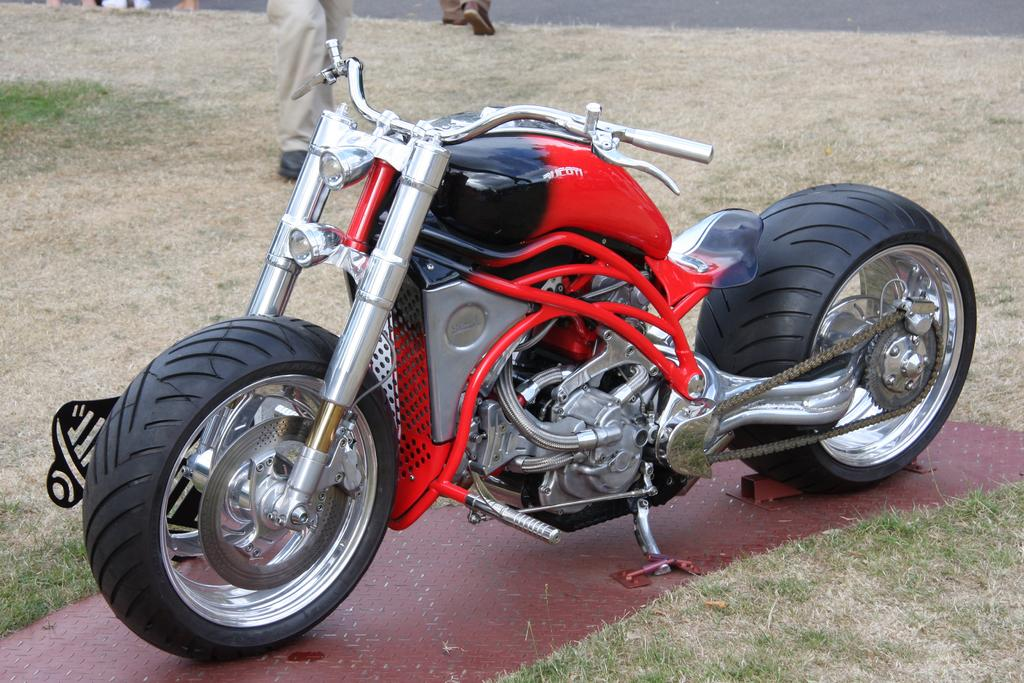What is the main subject in the middle of the picture? There is a bike in the middle of the picture. What color is the bike? The bike is red. What type of terrain is visible at the bottom of the picture? There is grass at the bottom of the picture. Can you describe the human presence in the image? Human legs are visible beside the grass. What type of knowledge is the man sharing with the bike in the image? There is no man present in the image, and therefore no knowledge can be shared with the bike. 